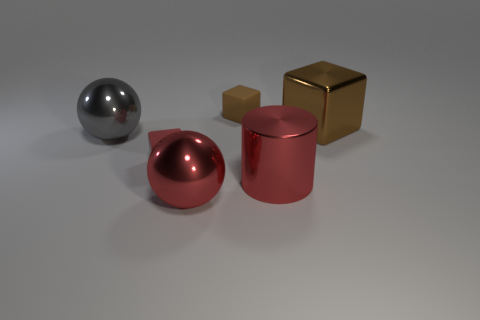Add 4 small objects. How many objects exist? 10 Subtract all spheres. How many objects are left? 4 Add 5 red balls. How many red balls exist? 6 Subtract 0 blue cylinders. How many objects are left? 6 Subtract all red matte spheres. Subtract all gray things. How many objects are left? 5 Add 3 metallic cylinders. How many metallic cylinders are left? 4 